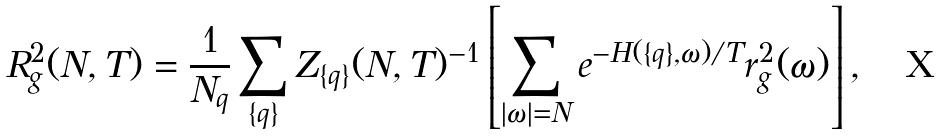<formula> <loc_0><loc_0><loc_500><loc_500>R _ { g } ^ { 2 } ( N , T ) = \frac { 1 } { N _ { q } } \sum _ { \{ q \} } Z _ { \{ q \} } ( N , T ) ^ { - 1 } \left [ { \sum _ { | \omega | = N } e ^ { - H ( \{ q \} , \omega ) / T } r _ { g } ^ { 2 } ( \omega ) } \right ] ,</formula> 